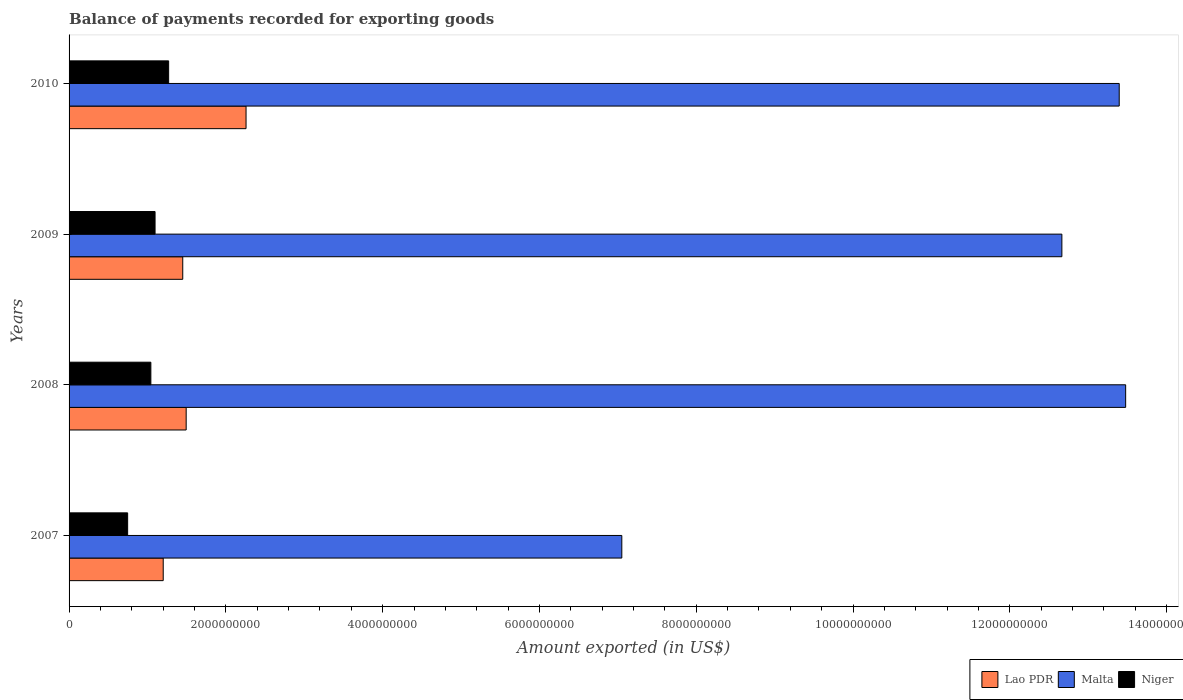How many different coloured bars are there?
Offer a terse response. 3. How many groups of bars are there?
Give a very brief answer. 4. Are the number of bars per tick equal to the number of legend labels?
Ensure brevity in your answer.  Yes. How many bars are there on the 1st tick from the bottom?
Your response must be concise. 3. What is the amount exported in Niger in 2010?
Your response must be concise. 1.27e+09. Across all years, what is the maximum amount exported in Malta?
Offer a very short reply. 1.35e+1. Across all years, what is the minimum amount exported in Malta?
Offer a terse response. 7.05e+09. In which year was the amount exported in Lao PDR maximum?
Ensure brevity in your answer.  2010. What is the total amount exported in Lao PDR in the graph?
Keep it short and to the point. 6.40e+09. What is the difference between the amount exported in Niger in 2008 and that in 2009?
Make the answer very short. -5.36e+07. What is the difference between the amount exported in Lao PDR in 2009 and the amount exported in Niger in 2008?
Offer a terse response. 4.07e+08. What is the average amount exported in Lao PDR per year?
Give a very brief answer. 1.60e+09. In the year 2009, what is the difference between the amount exported in Lao PDR and amount exported in Niger?
Offer a terse response. 3.53e+08. What is the ratio of the amount exported in Lao PDR in 2008 to that in 2010?
Ensure brevity in your answer.  0.66. What is the difference between the highest and the second highest amount exported in Lao PDR?
Your response must be concise. 7.64e+08. What is the difference between the highest and the lowest amount exported in Niger?
Your answer should be compact. 5.23e+08. In how many years, is the amount exported in Lao PDR greater than the average amount exported in Lao PDR taken over all years?
Ensure brevity in your answer.  1. What does the 2nd bar from the top in 2009 represents?
Offer a very short reply. Malta. What does the 3rd bar from the bottom in 2007 represents?
Provide a short and direct response. Niger. Is it the case that in every year, the sum of the amount exported in Niger and amount exported in Lao PDR is greater than the amount exported in Malta?
Offer a very short reply. No. Are all the bars in the graph horizontal?
Offer a very short reply. Yes. Are the values on the major ticks of X-axis written in scientific E-notation?
Keep it short and to the point. No. Does the graph contain grids?
Offer a terse response. No. How many legend labels are there?
Provide a succinct answer. 3. What is the title of the graph?
Make the answer very short. Balance of payments recorded for exporting goods. What is the label or title of the X-axis?
Offer a terse response. Amount exported (in US$). What is the Amount exported (in US$) in Lao PDR in 2007?
Make the answer very short. 1.20e+09. What is the Amount exported (in US$) of Malta in 2007?
Keep it short and to the point. 7.05e+09. What is the Amount exported (in US$) in Niger in 2007?
Ensure brevity in your answer.  7.47e+08. What is the Amount exported (in US$) of Lao PDR in 2008?
Provide a short and direct response. 1.49e+09. What is the Amount exported (in US$) of Malta in 2008?
Keep it short and to the point. 1.35e+1. What is the Amount exported (in US$) of Niger in 2008?
Offer a very short reply. 1.04e+09. What is the Amount exported (in US$) in Lao PDR in 2009?
Your response must be concise. 1.45e+09. What is the Amount exported (in US$) of Malta in 2009?
Your answer should be compact. 1.27e+1. What is the Amount exported (in US$) in Niger in 2009?
Your answer should be very brief. 1.10e+09. What is the Amount exported (in US$) in Lao PDR in 2010?
Give a very brief answer. 2.26e+09. What is the Amount exported (in US$) of Malta in 2010?
Keep it short and to the point. 1.34e+1. What is the Amount exported (in US$) in Niger in 2010?
Make the answer very short. 1.27e+09. Across all years, what is the maximum Amount exported (in US$) in Lao PDR?
Ensure brevity in your answer.  2.26e+09. Across all years, what is the maximum Amount exported (in US$) of Malta?
Give a very brief answer. 1.35e+1. Across all years, what is the maximum Amount exported (in US$) in Niger?
Keep it short and to the point. 1.27e+09. Across all years, what is the minimum Amount exported (in US$) in Lao PDR?
Your response must be concise. 1.20e+09. Across all years, what is the minimum Amount exported (in US$) in Malta?
Make the answer very short. 7.05e+09. Across all years, what is the minimum Amount exported (in US$) in Niger?
Offer a terse response. 7.47e+08. What is the total Amount exported (in US$) in Lao PDR in the graph?
Provide a short and direct response. 6.40e+09. What is the total Amount exported (in US$) of Malta in the graph?
Make the answer very short. 4.66e+1. What is the total Amount exported (in US$) in Niger in the graph?
Offer a very short reply. 4.16e+09. What is the difference between the Amount exported (in US$) in Lao PDR in 2007 and that in 2008?
Provide a short and direct response. -2.93e+08. What is the difference between the Amount exported (in US$) in Malta in 2007 and that in 2008?
Your answer should be very brief. -6.43e+09. What is the difference between the Amount exported (in US$) of Niger in 2007 and that in 2008?
Your response must be concise. -2.96e+08. What is the difference between the Amount exported (in US$) in Lao PDR in 2007 and that in 2009?
Keep it short and to the point. -2.49e+08. What is the difference between the Amount exported (in US$) of Malta in 2007 and that in 2009?
Give a very brief answer. -5.61e+09. What is the difference between the Amount exported (in US$) in Niger in 2007 and that in 2009?
Your answer should be compact. -3.50e+08. What is the difference between the Amount exported (in US$) in Lao PDR in 2007 and that in 2010?
Offer a terse response. -1.06e+09. What is the difference between the Amount exported (in US$) in Malta in 2007 and that in 2010?
Keep it short and to the point. -6.34e+09. What is the difference between the Amount exported (in US$) in Niger in 2007 and that in 2010?
Offer a very short reply. -5.23e+08. What is the difference between the Amount exported (in US$) in Lao PDR in 2008 and that in 2009?
Provide a succinct answer. 4.36e+07. What is the difference between the Amount exported (in US$) in Malta in 2008 and that in 2009?
Keep it short and to the point. 8.14e+08. What is the difference between the Amount exported (in US$) in Niger in 2008 and that in 2009?
Your response must be concise. -5.36e+07. What is the difference between the Amount exported (in US$) in Lao PDR in 2008 and that in 2010?
Make the answer very short. -7.64e+08. What is the difference between the Amount exported (in US$) of Malta in 2008 and that in 2010?
Your answer should be very brief. 8.22e+07. What is the difference between the Amount exported (in US$) in Niger in 2008 and that in 2010?
Offer a very short reply. -2.27e+08. What is the difference between the Amount exported (in US$) of Lao PDR in 2009 and that in 2010?
Keep it short and to the point. -8.07e+08. What is the difference between the Amount exported (in US$) of Malta in 2009 and that in 2010?
Make the answer very short. -7.32e+08. What is the difference between the Amount exported (in US$) of Niger in 2009 and that in 2010?
Your answer should be very brief. -1.73e+08. What is the difference between the Amount exported (in US$) in Lao PDR in 2007 and the Amount exported (in US$) in Malta in 2008?
Provide a succinct answer. -1.23e+1. What is the difference between the Amount exported (in US$) in Lao PDR in 2007 and the Amount exported (in US$) in Niger in 2008?
Ensure brevity in your answer.  1.58e+08. What is the difference between the Amount exported (in US$) of Malta in 2007 and the Amount exported (in US$) of Niger in 2008?
Your answer should be compact. 6.01e+09. What is the difference between the Amount exported (in US$) of Lao PDR in 2007 and the Amount exported (in US$) of Malta in 2009?
Make the answer very short. -1.15e+1. What is the difference between the Amount exported (in US$) of Lao PDR in 2007 and the Amount exported (in US$) of Niger in 2009?
Keep it short and to the point. 1.04e+08. What is the difference between the Amount exported (in US$) in Malta in 2007 and the Amount exported (in US$) in Niger in 2009?
Give a very brief answer. 5.95e+09. What is the difference between the Amount exported (in US$) in Lao PDR in 2007 and the Amount exported (in US$) in Malta in 2010?
Offer a terse response. -1.22e+1. What is the difference between the Amount exported (in US$) of Lao PDR in 2007 and the Amount exported (in US$) of Niger in 2010?
Offer a terse response. -6.92e+07. What is the difference between the Amount exported (in US$) of Malta in 2007 and the Amount exported (in US$) of Niger in 2010?
Your response must be concise. 5.78e+09. What is the difference between the Amount exported (in US$) of Lao PDR in 2008 and the Amount exported (in US$) of Malta in 2009?
Make the answer very short. -1.12e+1. What is the difference between the Amount exported (in US$) of Lao PDR in 2008 and the Amount exported (in US$) of Niger in 2009?
Your answer should be compact. 3.97e+08. What is the difference between the Amount exported (in US$) of Malta in 2008 and the Amount exported (in US$) of Niger in 2009?
Offer a very short reply. 1.24e+1. What is the difference between the Amount exported (in US$) in Lao PDR in 2008 and the Amount exported (in US$) in Malta in 2010?
Keep it short and to the point. -1.19e+1. What is the difference between the Amount exported (in US$) in Lao PDR in 2008 and the Amount exported (in US$) in Niger in 2010?
Your answer should be compact. 2.23e+08. What is the difference between the Amount exported (in US$) of Malta in 2008 and the Amount exported (in US$) of Niger in 2010?
Ensure brevity in your answer.  1.22e+1. What is the difference between the Amount exported (in US$) of Lao PDR in 2009 and the Amount exported (in US$) of Malta in 2010?
Give a very brief answer. -1.19e+1. What is the difference between the Amount exported (in US$) in Lao PDR in 2009 and the Amount exported (in US$) in Niger in 2010?
Give a very brief answer. 1.80e+08. What is the difference between the Amount exported (in US$) of Malta in 2009 and the Amount exported (in US$) of Niger in 2010?
Make the answer very short. 1.14e+1. What is the average Amount exported (in US$) of Lao PDR per year?
Your response must be concise. 1.60e+09. What is the average Amount exported (in US$) of Malta per year?
Provide a short and direct response. 1.16e+1. What is the average Amount exported (in US$) of Niger per year?
Ensure brevity in your answer.  1.04e+09. In the year 2007, what is the difference between the Amount exported (in US$) of Lao PDR and Amount exported (in US$) of Malta?
Give a very brief answer. -5.85e+09. In the year 2007, what is the difference between the Amount exported (in US$) in Lao PDR and Amount exported (in US$) in Niger?
Offer a very short reply. 4.54e+08. In the year 2007, what is the difference between the Amount exported (in US$) of Malta and Amount exported (in US$) of Niger?
Provide a succinct answer. 6.30e+09. In the year 2008, what is the difference between the Amount exported (in US$) in Lao PDR and Amount exported (in US$) in Malta?
Keep it short and to the point. -1.20e+1. In the year 2008, what is the difference between the Amount exported (in US$) of Lao PDR and Amount exported (in US$) of Niger?
Ensure brevity in your answer.  4.50e+08. In the year 2008, what is the difference between the Amount exported (in US$) of Malta and Amount exported (in US$) of Niger?
Offer a terse response. 1.24e+1. In the year 2009, what is the difference between the Amount exported (in US$) of Lao PDR and Amount exported (in US$) of Malta?
Keep it short and to the point. -1.12e+1. In the year 2009, what is the difference between the Amount exported (in US$) in Lao PDR and Amount exported (in US$) in Niger?
Make the answer very short. 3.53e+08. In the year 2009, what is the difference between the Amount exported (in US$) in Malta and Amount exported (in US$) in Niger?
Offer a very short reply. 1.16e+1. In the year 2010, what is the difference between the Amount exported (in US$) in Lao PDR and Amount exported (in US$) in Malta?
Ensure brevity in your answer.  -1.11e+1. In the year 2010, what is the difference between the Amount exported (in US$) in Lao PDR and Amount exported (in US$) in Niger?
Give a very brief answer. 9.87e+08. In the year 2010, what is the difference between the Amount exported (in US$) of Malta and Amount exported (in US$) of Niger?
Provide a short and direct response. 1.21e+1. What is the ratio of the Amount exported (in US$) of Lao PDR in 2007 to that in 2008?
Your answer should be very brief. 0.8. What is the ratio of the Amount exported (in US$) in Malta in 2007 to that in 2008?
Offer a very short reply. 0.52. What is the ratio of the Amount exported (in US$) in Niger in 2007 to that in 2008?
Provide a succinct answer. 0.72. What is the ratio of the Amount exported (in US$) of Lao PDR in 2007 to that in 2009?
Offer a terse response. 0.83. What is the ratio of the Amount exported (in US$) in Malta in 2007 to that in 2009?
Your response must be concise. 0.56. What is the ratio of the Amount exported (in US$) of Niger in 2007 to that in 2009?
Give a very brief answer. 0.68. What is the ratio of the Amount exported (in US$) in Lao PDR in 2007 to that in 2010?
Offer a very short reply. 0.53. What is the ratio of the Amount exported (in US$) in Malta in 2007 to that in 2010?
Keep it short and to the point. 0.53. What is the ratio of the Amount exported (in US$) in Niger in 2007 to that in 2010?
Make the answer very short. 0.59. What is the ratio of the Amount exported (in US$) of Lao PDR in 2008 to that in 2009?
Your answer should be compact. 1.03. What is the ratio of the Amount exported (in US$) in Malta in 2008 to that in 2009?
Ensure brevity in your answer.  1.06. What is the ratio of the Amount exported (in US$) of Niger in 2008 to that in 2009?
Make the answer very short. 0.95. What is the ratio of the Amount exported (in US$) in Lao PDR in 2008 to that in 2010?
Your answer should be very brief. 0.66. What is the ratio of the Amount exported (in US$) in Niger in 2008 to that in 2010?
Give a very brief answer. 0.82. What is the ratio of the Amount exported (in US$) of Lao PDR in 2009 to that in 2010?
Offer a very short reply. 0.64. What is the ratio of the Amount exported (in US$) in Malta in 2009 to that in 2010?
Give a very brief answer. 0.95. What is the ratio of the Amount exported (in US$) in Niger in 2009 to that in 2010?
Ensure brevity in your answer.  0.86. What is the difference between the highest and the second highest Amount exported (in US$) in Lao PDR?
Your answer should be compact. 7.64e+08. What is the difference between the highest and the second highest Amount exported (in US$) of Malta?
Provide a short and direct response. 8.22e+07. What is the difference between the highest and the second highest Amount exported (in US$) in Niger?
Offer a very short reply. 1.73e+08. What is the difference between the highest and the lowest Amount exported (in US$) in Lao PDR?
Give a very brief answer. 1.06e+09. What is the difference between the highest and the lowest Amount exported (in US$) in Malta?
Make the answer very short. 6.43e+09. What is the difference between the highest and the lowest Amount exported (in US$) of Niger?
Offer a very short reply. 5.23e+08. 